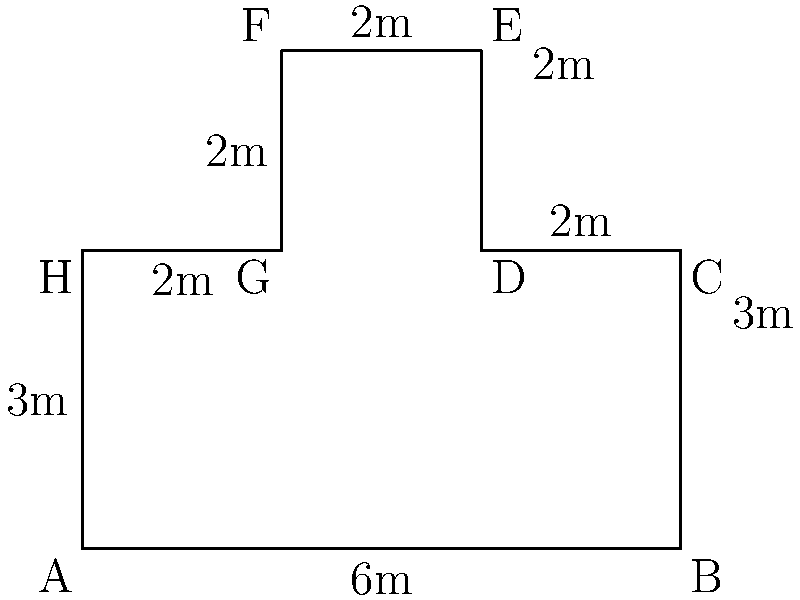As a data broker, you've acquired the floor plan of a competitor's irregularly shaped office. Calculate the perimeter of this office to determine the amount of security equipment needed to monitor the entire boundary. All measurements are in meters. To find the perimeter, we need to sum up the lengths of all sides of the office floor plan:

1. Side AB: 6m
2. Side BC: 3m
3. Side CD: 2m
4. Side DE: 2m
5. Side EF: 2m
6. Side FG: 2m
7. Side GH: 2m
8. Side HA: 3m

Calculate the sum:
$$\text{Perimeter} = 6 + 3 + 2 + 2 + 2 + 2 + 2 + 3 = 22\text{ m}$$

Therefore, the perimeter of the office is 22 meters.
Answer: 22 m 